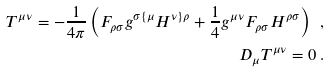<formula> <loc_0><loc_0><loc_500><loc_500>T ^ { \mu \nu } = - \frac { 1 } { 4 \pi } \left ( F _ { \rho \sigma } g ^ { \sigma \{ \mu } H ^ { \nu \} \rho } + \frac { 1 } { 4 } g ^ { \mu \nu } F _ { \rho \sigma } H ^ { \rho \sigma } \right ) \ , \\ D _ { \mu } T ^ { \mu \nu } = 0 \ .</formula> 